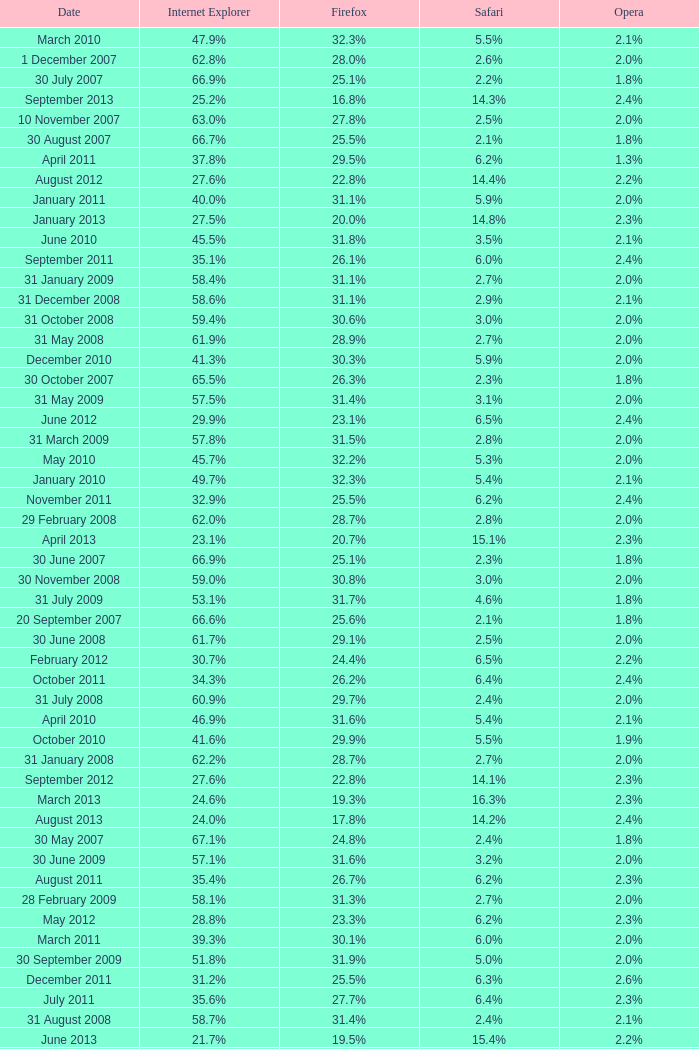When did internet explorer reach a 6 31 January 2008. 